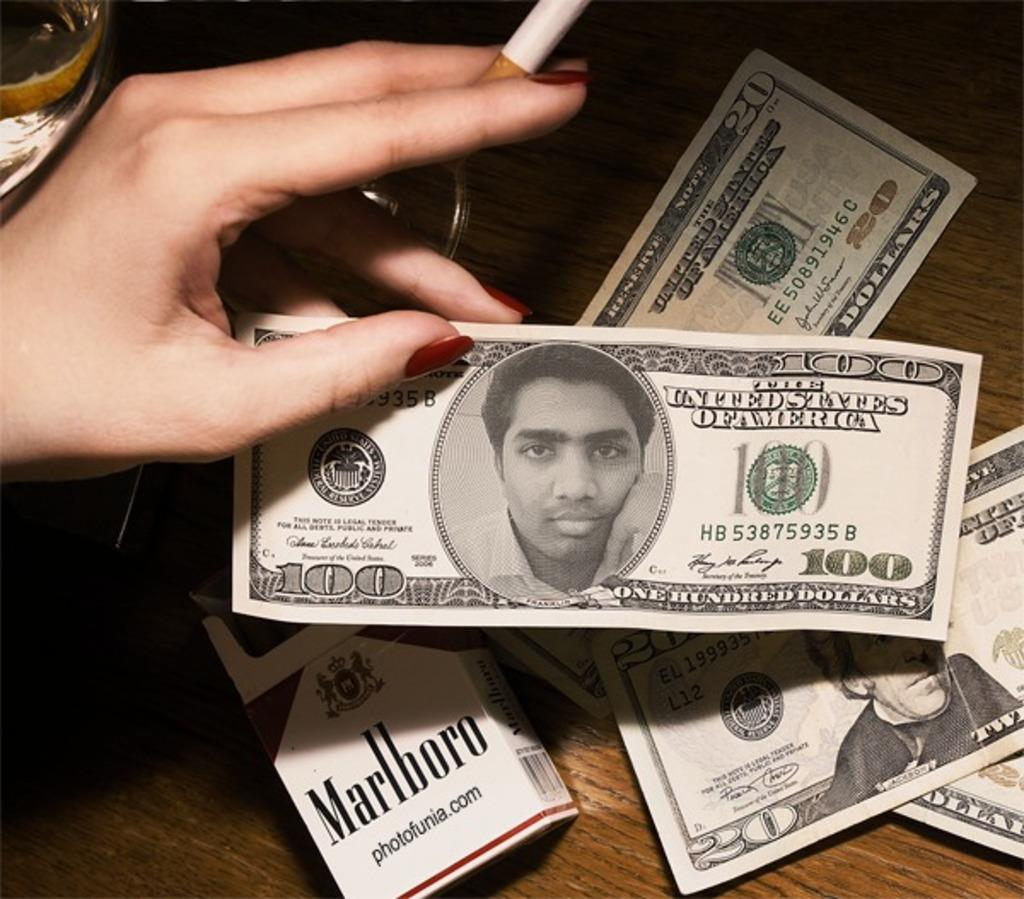<image>
Write a terse but informative summary of the picture. A pack of Marlboro cigarettes sits next to several denominations of United States Dollar Bills 